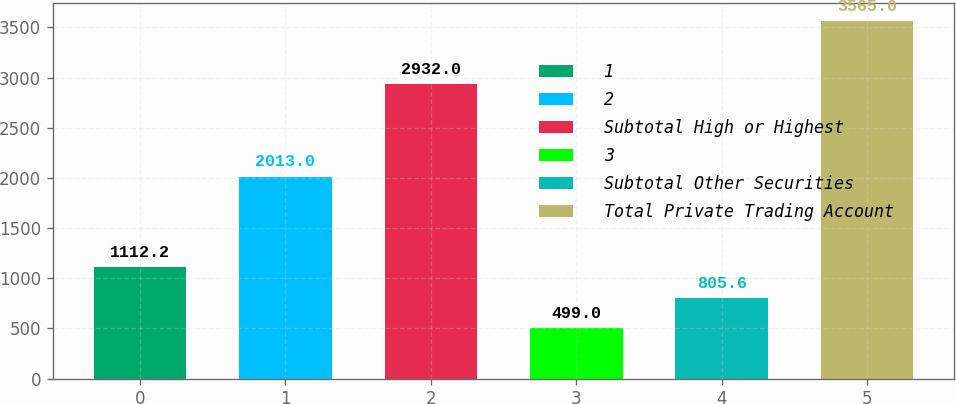<chart> <loc_0><loc_0><loc_500><loc_500><bar_chart><fcel>1<fcel>2<fcel>Subtotal High or Highest<fcel>3<fcel>Subtotal Other Securities<fcel>Total Private Trading Account<nl><fcel>1112.2<fcel>2013<fcel>2932<fcel>499<fcel>805.6<fcel>3565<nl></chart> 